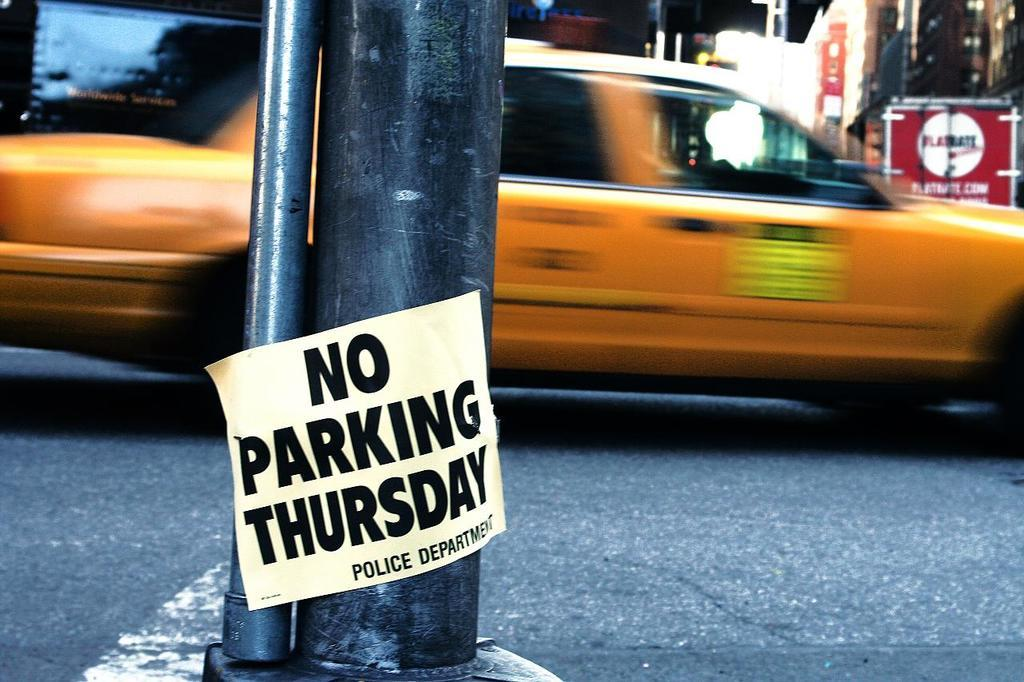Provide a one-sentence caption for the provided image. Taxi car riding by with no parking Thursday sign on a pole. 